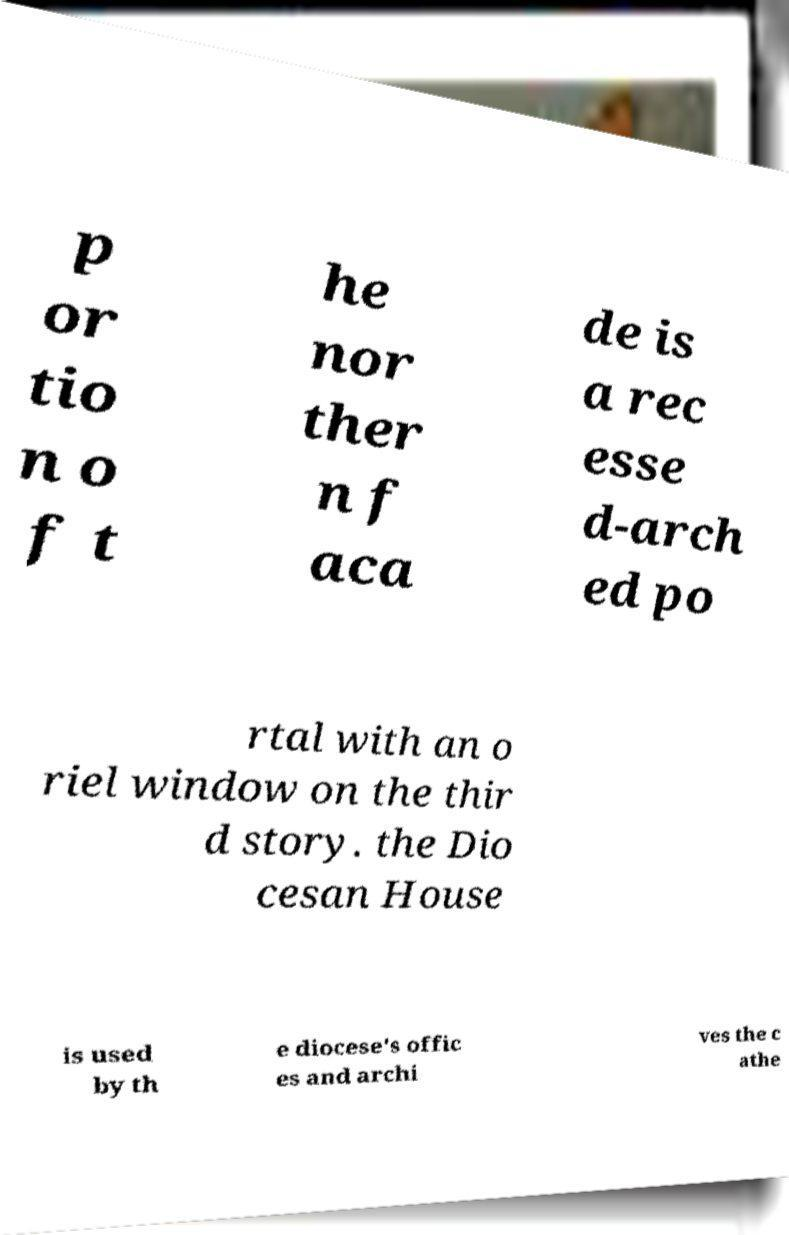Can you accurately transcribe the text from the provided image for me? p or tio n o f t he nor ther n f aca de is a rec esse d-arch ed po rtal with an o riel window on the thir d story. the Dio cesan House is used by th e diocese's offic es and archi ves the c athe 